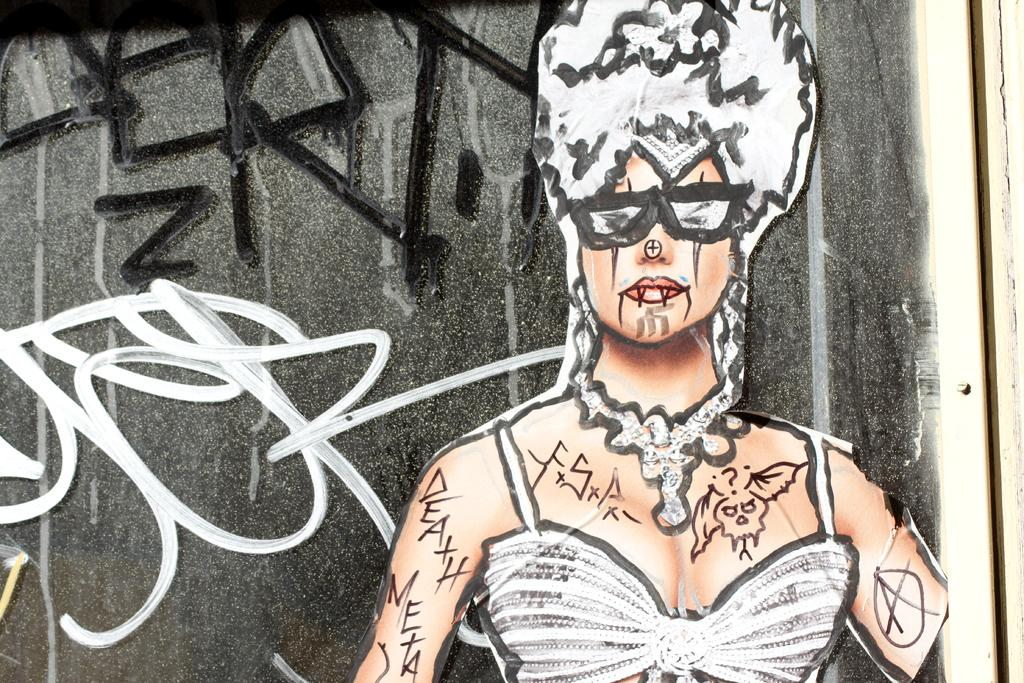What is present on the wall in the image? There is a painting of a woman on the wall. Can you describe the painting in more detail? The painting is of a woman, but no further details are provided in the facts. What else can be seen in the image besides the wall and the painting? The facts do not mention any other elements in the image. What type of produce is hanging from the ceiling in the image? There is no produce or ceiling present in the image; it only features a wall with a painting of a woman. 